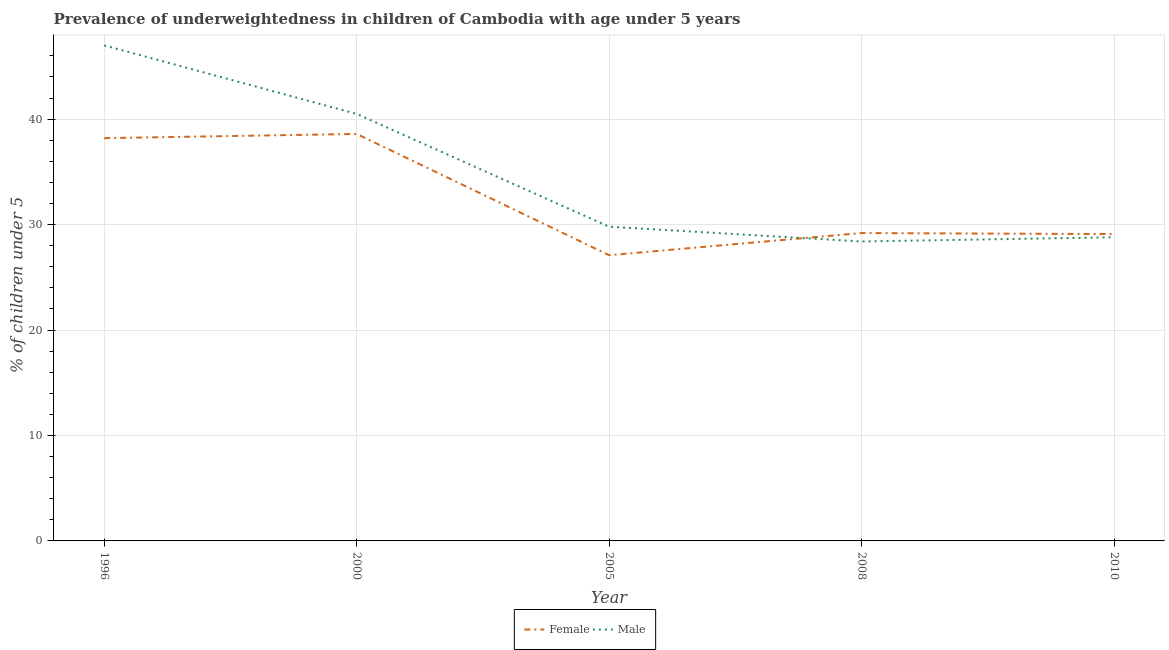Does the line corresponding to percentage of underweighted male children intersect with the line corresponding to percentage of underweighted female children?
Offer a terse response. Yes. What is the percentage of underweighted female children in 2010?
Offer a terse response. 29.1. Across all years, what is the maximum percentage of underweighted female children?
Your response must be concise. 38.6. Across all years, what is the minimum percentage of underweighted female children?
Make the answer very short. 27.1. In which year was the percentage of underweighted female children minimum?
Keep it short and to the point. 2005. What is the total percentage of underweighted female children in the graph?
Offer a very short reply. 162.2. What is the difference between the percentage of underweighted male children in 2005 and that in 2008?
Provide a succinct answer. 1.4. What is the difference between the percentage of underweighted male children in 1996 and the percentage of underweighted female children in 2000?
Make the answer very short. 8.4. What is the average percentage of underweighted male children per year?
Offer a terse response. 34.9. In the year 1996, what is the difference between the percentage of underweighted male children and percentage of underweighted female children?
Offer a terse response. 8.8. In how many years, is the percentage of underweighted female children greater than 20 %?
Offer a very short reply. 5. What is the ratio of the percentage of underweighted female children in 2005 to that in 2008?
Keep it short and to the point. 0.93. Is the percentage of underweighted male children in 2005 less than that in 2008?
Your response must be concise. No. Is the difference between the percentage of underweighted female children in 1996 and 2000 greater than the difference between the percentage of underweighted male children in 1996 and 2000?
Offer a terse response. No. What is the difference between the highest and the lowest percentage of underweighted male children?
Provide a short and direct response. 18.6. Does the percentage of underweighted male children monotonically increase over the years?
Provide a short and direct response. No. Is the percentage of underweighted female children strictly greater than the percentage of underweighted male children over the years?
Provide a short and direct response. No. How many lines are there?
Make the answer very short. 2. How many years are there in the graph?
Offer a very short reply. 5. Are the values on the major ticks of Y-axis written in scientific E-notation?
Your response must be concise. No. Where does the legend appear in the graph?
Make the answer very short. Bottom center. How many legend labels are there?
Give a very brief answer. 2. How are the legend labels stacked?
Offer a very short reply. Horizontal. What is the title of the graph?
Your response must be concise. Prevalence of underweightedness in children of Cambodia with age under 5 years. Does "Exports" appear as one of the legend labels in the graph?
Provide a succinct answer. No. What is the label or title of the X-axis?
Your answer should be compact. Year. What is the label or title of the Y-axis?
Your answer should be compact.  % of children under 5. What is the  % of children under 5 in Female in 1996?
Provide a short and direct response. 38.2. What is the  % of children under 5 of Female in 2000?
Your answer should be very brief. 38.6. What is the  % of children under 5 in Male in 2000?
Provide a succinct answer. 40.5. What is the  % of children under 5 of Female in 2005?
Give a very brief answer. 27.1. What is the  % of children under 5 of Male in 2005?
Give a very brief answer. 29.8. What is the  % of children under 5 in Female in 2008?
Provide a short and direct response. 29.2. What is the  % of children under 5 of Male in 2008?
Keep it short and to the point. 28.4. What is the  % of children under 5 of Female in 2010?
Ensure brevity in your answer.  29.1. What is the  % of children under 5 of Male in 2010?
Keep it short and to the point. 28.8. Across all years, what is the maximum  % of children under 5 in Female?
Your answer should be very brief. 38.6. Across all years, what is the maximum  % of children under 5 of Male?
Keep it short and to the point. 47. Across all years, what is the minimum  % of children under 5 in Female?
Your answer should be compact. 27.1. Across all years, what is the minimum  % of children under 5 of Male?
Offer a terse response. 28.4. What is the total  % of children under 5 in Female in the graph?
Offer a terse response. 162.2. What is the total  % of children under 5 of Male in the graph?
Provide a succinct answer. 174.5. What is the difference between the  % of children under 5 in Male in 1996 and that in 2005?
Make the answer very short. 17.2. What is the difference between the  % of children under 5 of Female in 1996 and that in 2008?
Provide a succinct answer. 9. What is the difference between the  % of children under 5 in Female in 1996 and that in 2010?
Ensure brevity in your answer.  9.1. What is the difference between the  % of children under 5 in Male in 1996 and that in 2010?
Provide a succinct answer. 18.2. What is the difference between the  % of children under 5 in Female in 2000 and that in 2005?
Make the answer very short. 11.5. What is the difference between the  % of children under 5 in Female in 2000 and that in 2008?
Offer a terse response. 9.4. What is the difference between the  % of children under 5 of Male in 2000 and that in 2008?
Give a very brief answer. 12.1. What is the difference between the  % of children under 5 of Female in 2000 and that in 2010?
Provide a succinct answer. 9.5. What is the difference between the  % of children under 5 in Male in 2005 and that in 2008?
Your answer should be compact. 1.4. What is the difference between the  % of children under 5 of Female in 2005 and that in 2010?
Provide a succinct answer. -2. What is the difference between the  % of children under 5 of Male in 2005 and that in 2010?
Offer a terse response. 1. What is the difference between the  % of children under 5 of Female in 2008 and that in 2010?
Ensure brevity in your answer.  0.1. What is the difference between the  % of children under 5 in Male in 2008 and that in 2010?
Provide a short and direct response. -0.4. What is the difference between the  % of children under 5 of Female in 1996 and the  % of children under 5 of Male in 2000?
Ensure brevity in your answer.  -2.3. What is the difference between the  % of children under 5 in Female in 1996 and the  % of children under 5 in Male in 2005?
Provide a short and direct response. 8.4. What is the difference between the  % of children under 5 in Female in 1996 and the  % of children under 5 in Male in 2008?
Provide a succinct answer. 9.8. What is the difference between the  % of children under 5 of Female in 2000 and the  % of children under 5 of Male in 2008?
Your answer should be compact. 10.2. What is the difference between the  % of children under 5 in Female in 2005 and the  % of children under 5 in Male in 2008?
Provide a succinct answer. -1.3. What is the difference between the  % of children under 5 of Female in 2008 and the  % of children under 5 of Male in 2010?
Provide a succinct answer. 0.4. What is the average  % of children under 5 of Female per year?
Keep it short and to the point. 32.44. What is the average  % of children under 5 of Male per year?
Your answer should be compact. 34.9. In the year 2005, what is the difference between the  % of children under 5 in Female and  % of children under 5 in Male?
Offer a very short reply. -2.7. In the year 2008, what is the difference between the  % of children under 5 of Female and  % of children under 5 of Male?
Your answer should be very brief. 0.8. What is the ratio of the  % of children under 5 of Male in 1996 to that in 2000?
Offer a very short reply. 1.16. What is the ratio of the  % of children under 5 in Female in 1996 to that in 2005?
Make the answer very short. 1.41. What is the ratio of the  % of children under 5 in Male in 1996 to that in 2005?
Offer a terse response. 1.58. What is the ratio of the  % of children under 5 in Female in 1996 to that in 2008?
Your answer should be very brief. 1.31. What is the ratio of the  % of children under 5 in Male in 1996 to that in 2008?
Your answer should be very brief. 1.65. What is the ratio of the  % of children under 5 of Female in 1996 to that in 2010?
Your answer should be very brief. 1.31. What is the ratio of the  % of children under 5 of Male in 1996 to that in 2010?
Offer a terse response. 1.63. What is the ratio of the  % of children under 5 of Female in 2000 to that in 2005?
Your answer should be compact. 1.42. What is the ratio of the  % of children under 5 in Male in 2000 to that in 2005?
Provide a succinct answer. 1.36. What is the ratio of the  % of children under 5 in Female in 2000 to that in 2008?
Make the answer very short. 1.32. What is the ratio of the  % of children under 5 in Male in 2000 to that in 2008?
Give a very brief answer. 1.43. What is the ratio of the  % of children under 5 of Female in 2000 to that in 2010?
Your response must be concise. 1.33. What is the ratio of the  % of children under 5 of Male in 2000 to that in 2010?
Provide a short and direct response. 1.41. What is the ratio of the  % of children under 5 in Female in 2005 to that in 2008?
Your answer should be compact. 0.93. What is the ratio of the  % of children under 5 of Male in 2005 to that in 2008?
Offer a terse response. 1.05. What is the ratio of the  % of children under 5 in Female in 2005 to that in 2010?
Offer a very short reply. 0.93. What is the ratio of the  % of children under 5 of Male in 2005 to that in 2010?
Provide a short and direct response. 1.03. What is the ratio of the  % of children under 5 in Female in 2008 to that in 2010?
Make the answer very short. 1. What is the ratio of the  % of children under 5 of Male in 2008 to that in 2010?
Give a very brief answer. 0.99. 